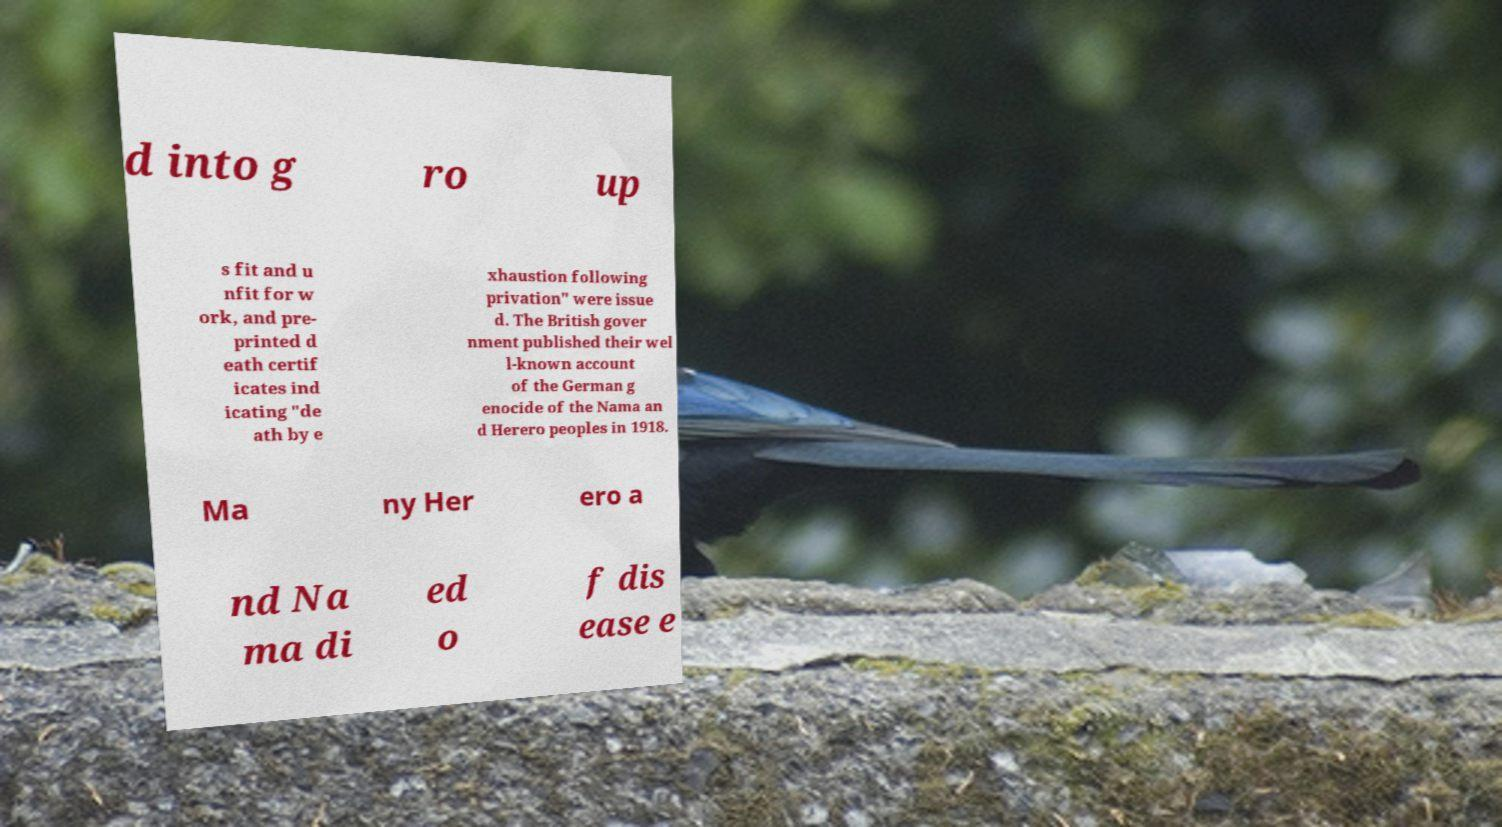Could you extract and type out the text from this image? d into g ro up s fit and u nfit for w ork, and pre- printed d eath certif icates ind icating "de ath by e xhaustion following privation" were issue d. The British gover nment published their wel l-known account of the German g enocide of the Nama an d Herero peoples in 1918. Ma ny Her ero a nd Na ma di ed o f dis ease e 